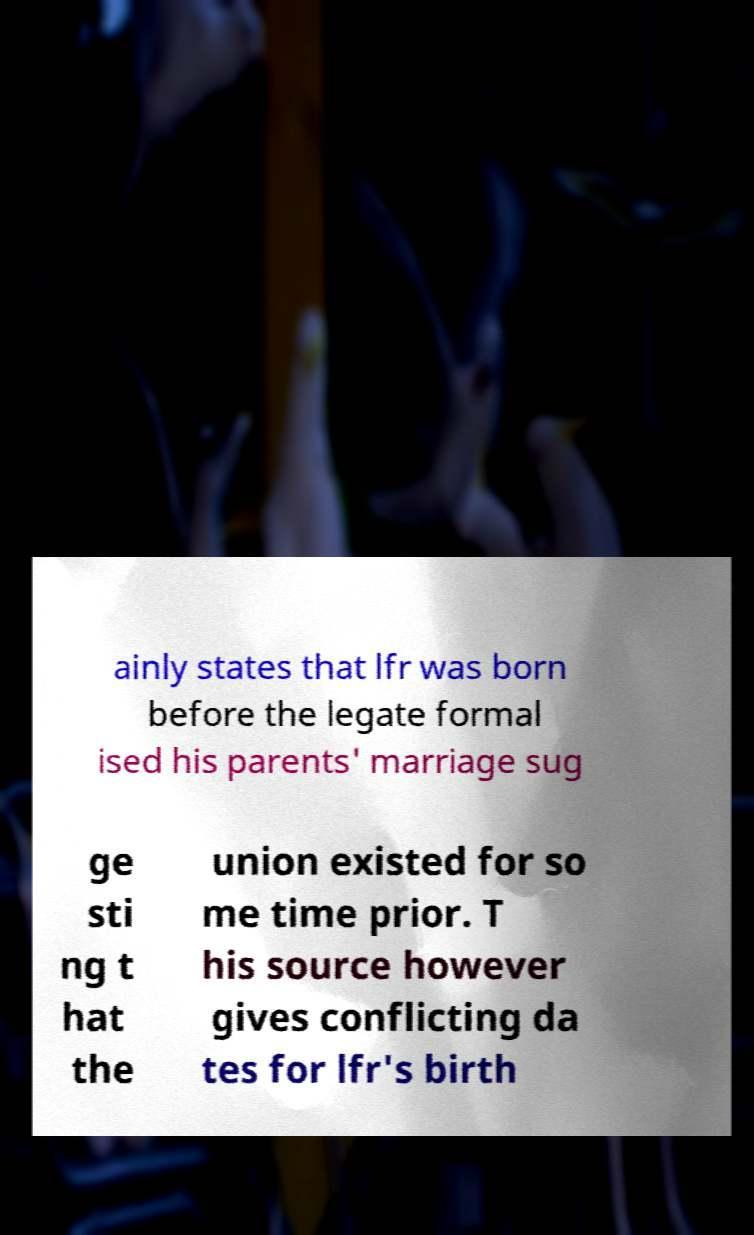Can you read and provide the text displayed in the image?This photo seems to have some interesting text. Can you extract and type it out for me? ainly states that lfr was born before the legate formal ised his parents' marriage sug ge sti ng t hat the union existed for so me time prior. T his source however gives conflicting da tes for lfr's birth 